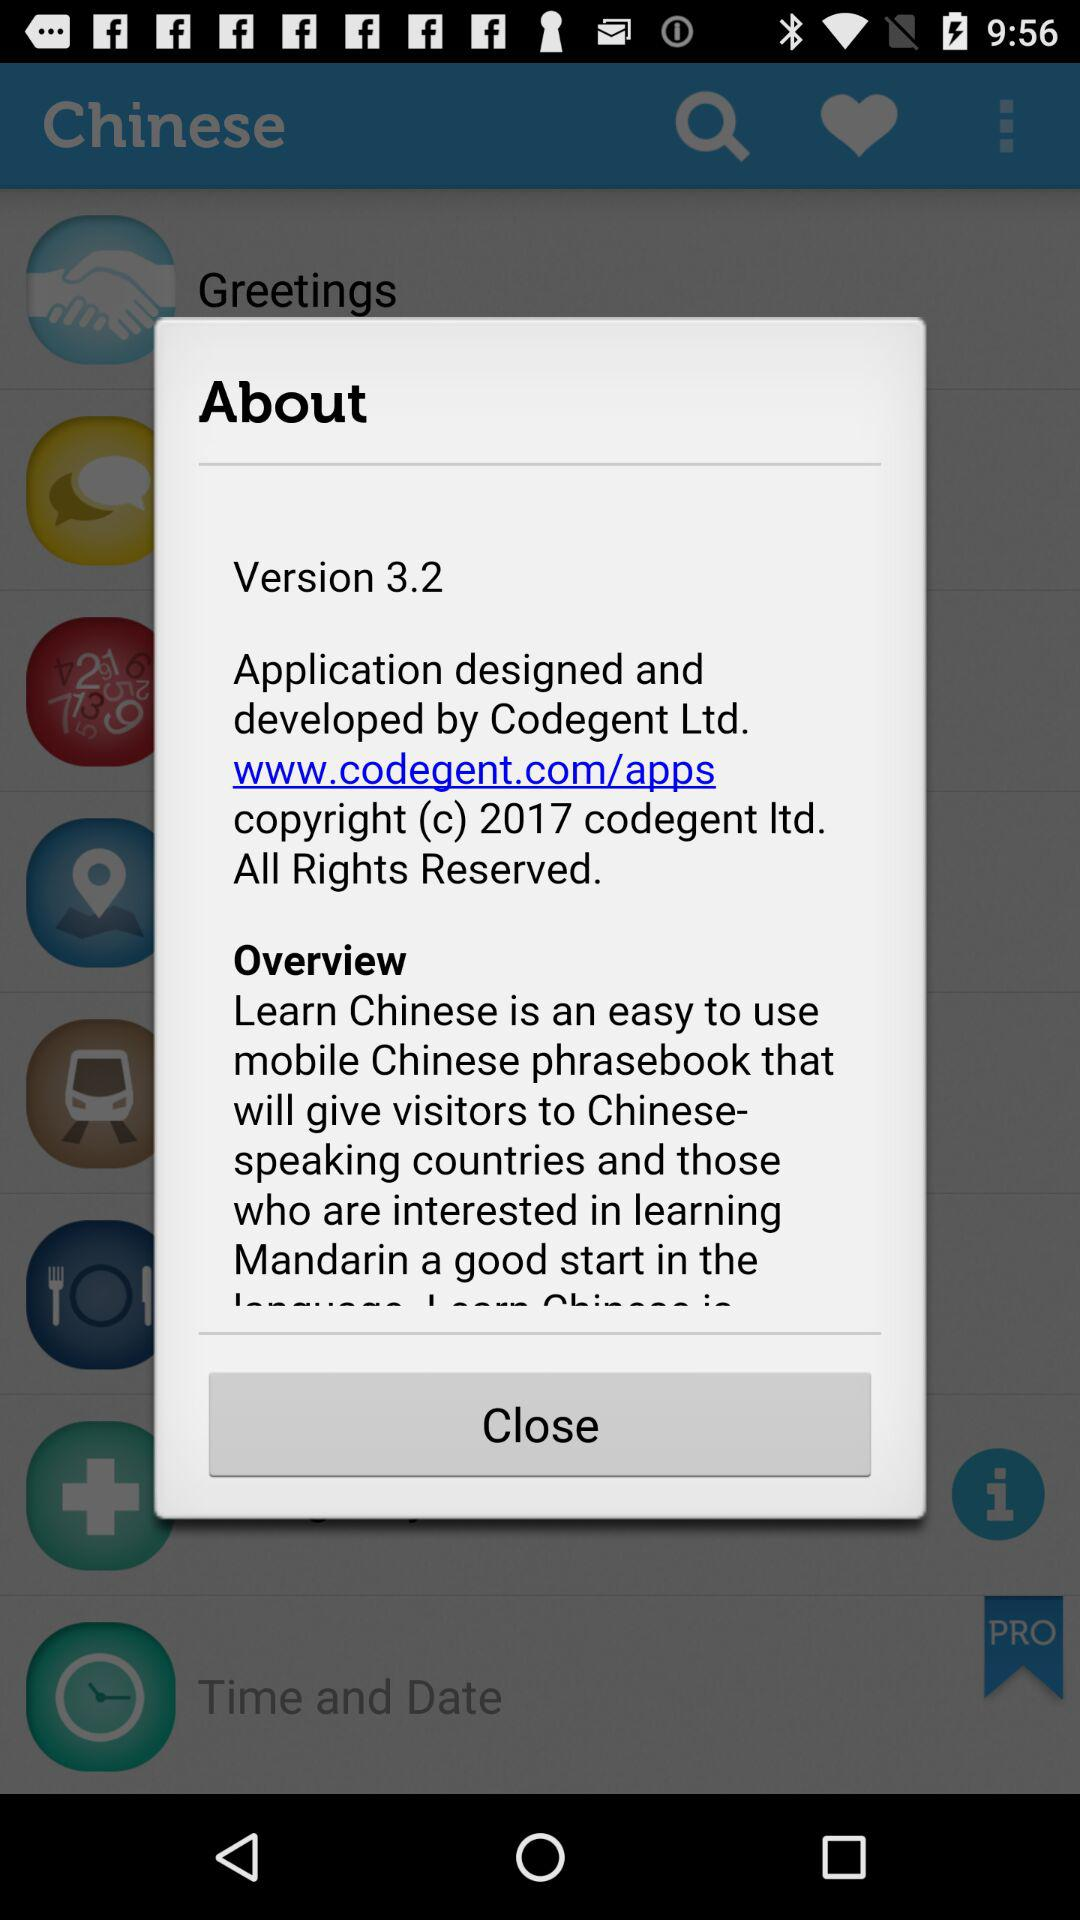What is the version? The version is 3.2. 